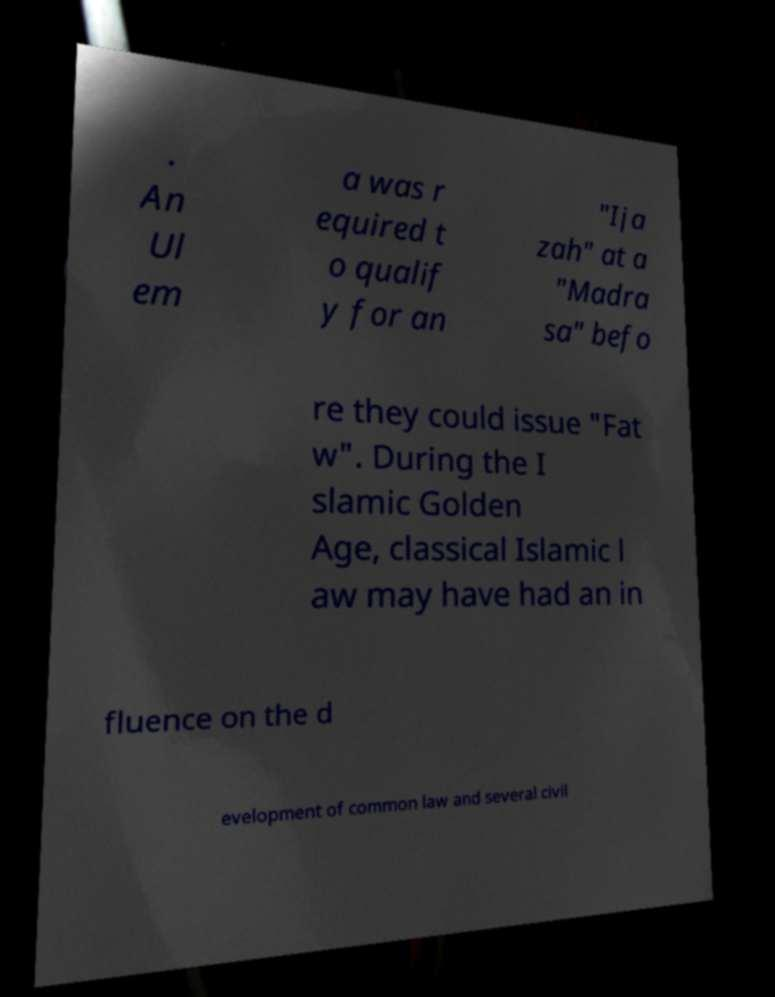For documentation purposes, I need the text within this image transcribed. Could you provide that? . An Ul em a was r equired t o qualif y for an "Ija zah" at a "Madra sa" befo re they could issue "Fat w". During the I slamic Golden Age, classical Islamic l aw may have had an in fluence on the d evelopment of common law and several civil 